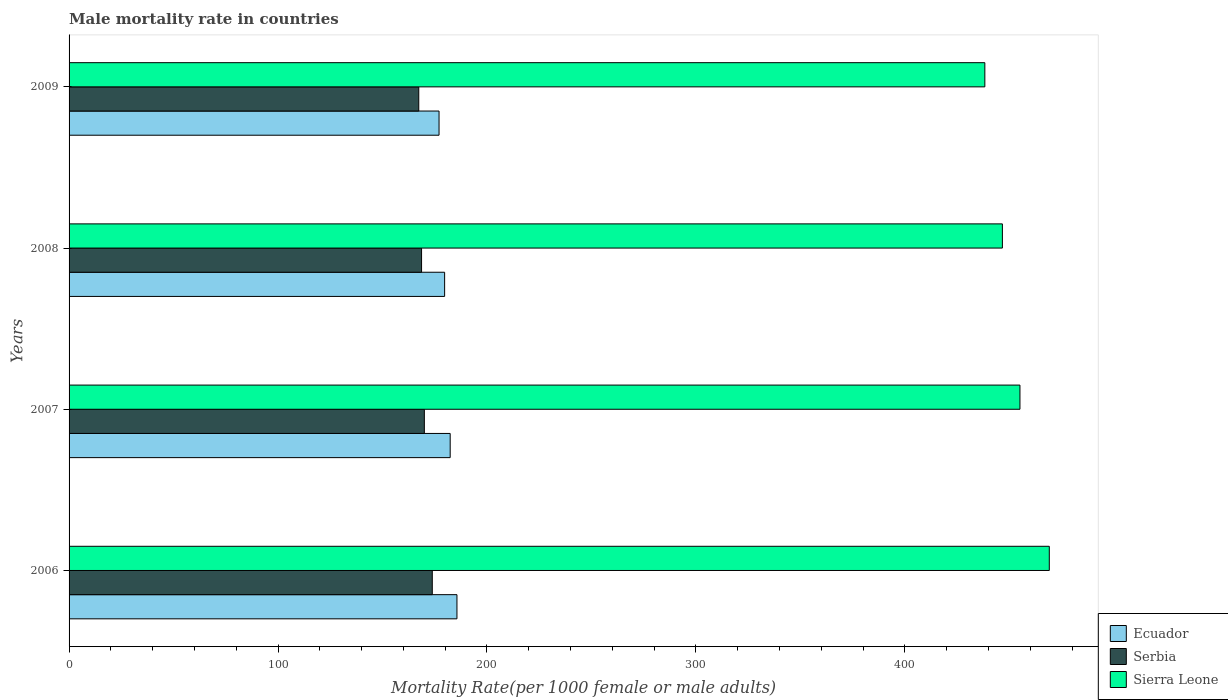How many different coloured bars are there?
Provide a short and direct response. 3. Are the number of bars on each tick of the Y-axis equal?
Your answer should be very brief. Yes. How many bars are there on the 4th tick from the bottom?
Offer a terse response. 3. What is the label of the 4th group of bars from the top?
Offer a very short reply. 2006. What is the male mortality rate in Ecuador in 2007?
Your response must be concise. 182.4. Across all years, what is the maximum male mortality rate in Serbia?
Ensure brevity in your answer.  173.83. Across all years, what is the minimum male mortality rate in Sierra Leone?
Provide a succinct answer. 438.28. What is the total male mortality rate in Ecuador in the graph?
Provide a short and direct response. 724.83. What is the difference between the male mortality rate in Serbia in 2007 and that in 2008?
Ensure brevity in your answer.  1.34. What is the difference between the male mortality rate in Serbia in 2009 and the male mortality rate in Sierra Leone in 2008?
Give a very brief answer. -279.32. What is the average male mortality rate in Sierra Leone per year?
Keep it short and to the point. 452.29. In the year 2006, what is the difference between the male mortality rate in Sierra Leone and male mortality rate in Serbia?
Offer a very short reply. 295.29. In how many years, is the male mortality rate in Serbia greater than 280 ?
Give a very brief answer. 0. What is the ratio of the male mortality rate in Serbia in 2007 to that in 2009?
Give a very brief answer. 1.02. What is the difference between the highest and the second highest male mortality rate in Serbia?
Give a very brief answer. 3.8. What is the difference between the highest and the lowest male mortality rate in Sierra Leone?
Ensure brevity in your answer.  30.85. What does the 1st bar from the top in 2009 represents?
Make the answer very short. Sierra Leone. What does the 3rd bar from the bottom in 2008 represents?
Your answer should be compact. Sierra Leone. Is it the case that in every year, the sum of the male mortality rate in Serbia and male mortality rate in Sierra Leone is greater than the male mortality rate in Ecuador?
Your response must be concise. Yes. How many years are there in the graph?
Provide a succinct answer. 4. Are the values on the major ticks of X-axis written in scientific E-notation?
Ensure brevity in your answer.  No. Does the graph contain any zero values?
Your answer should be very brief. No. What is the title of the graph?
Keep it short and to the point. Male mortality rate in countries. Does "Venezuela" appear as one of the legend labels in the graph?
Your response must be concise. No. What is the label or title of the X-axis?
Offer a very short reply. Mortality Rate(per 1000 female or male adults). What is the label or title of the Y-axis?
Ensure brevity in your answer.  Years. What is the Mortality Rate(per 1000 female or male adults) in Ecuador in 2006?
Your answer should be compact. 185.63. What is the Mortality Rate(per 1000 female or male adults) in Serbia in 2006?
Provide a succinct answer. 173.83. What is the Mortality Rate(per 1000 female or male adults) in Sierra Leone in 2006?
Provide a short and direct response. 469.12. What is the Mortality Rate(per 1000 female or male adults) of Ecuador in 2007?
Offer a terse response. 182.4. What is the Mortality Rate(per 1000 female or male adults) in Serbia in 2007?
Your answer should be very brief. 170.03. What is the Mortality Rate(per 1000 female or male adults) of Sierra Leone in 2007?
Provide a succinct answer. 455.08. What is the Mortality Rate(per 1000 female or male adults) in Ecuador in 2008?
Make the answer very short. 179.73. What is the Mortality Rate(per 1000 female or male adults) of Serbia in 2008?
Provide a succinct answer. 168.7. What is the Mortality Rate(per 1000 female or male adults) in Sierra Leone in 2008?
Make the answer very short. 446.68. What is the Mortality Rate(per 1000 female or male adults) of Ecuador in 2009?
Keep it short and to the point. 177.07. What is the Mortality Rate(per 1000 female or male adults) in Serbia in 2009?
Ensure brevity in your answer.  167.36. What is the Mortality Rate(per 1000 female or male adults) of Sierra Leone in 2009?
Offer a very short reply. 438.28. Across all years, what is the maximum Mortality Rate(per 1000 female or male adults) in Ecuador?
Provide a succinct answer. 185.63. Across all years, what is the maximum Mortality Rate(per 1000 female or male adults) in Serbia?
Offer a terse response. 173.83. Across all years, what is the maximum Mortality Rate(per 1000 female or male adults) in Sierra Leone?
Offer a very short reply. 469.12. Across all years, what is the minimum Mortality Rate(per 1000 female or male adults) of Ecuador?
Your answer should be very brief. 177.07. Across all years, what is the minimum Mortality Rate(per 1000 female or male adults) in Serbia?
Your answer should be very brief. 167.36. Across all years, what is the minimum Mortality Rate(per 1000 female or male adults) of Sierra Leone?
Make the answer very short. 438.28. What is the total Mortality Rate(per 1000 female or male adults) in Ecuador in the graph?
Provide a short and direct response. 724.83. What is the total Mortality Rate(per 1000 female or male adults) in Serbia in the graph?
Offer a terse response. 679.92. What is the total Mortality Rate(per 1000 female or male adults) in Sierra Leone in the graph?
Ensure brevity in your answer.  1809.15. What is the difference between the Mortality Rate(per 1000 female or male adults) in Ecuador in 2006 and that in 2007?
Give a very brief answer. 3.24. What is the difference between the Mortality Rate(per 1000 female or male adults) of Serbia in 2006 and that in 2007?
Ensure brevity in your answer.  3.8. What is the difference between the Mortality Rate(per 1000 female or male adults) in Sierra Leone in 2006 and that in 2007?
Offer a terse response. 14.04. What is the difference between the Mortality Rate(per 1000 female or male adults) of Ecuador in 2006 and that in 2008?
Keep it short and to the point. 5.9. What is the difference between the Mortality Rate(per 1000 female or male adults) of Serbia in 2006 and that in 2008?
Offer a terse response. 5.13. What is the difference between the Mortality Rate(per 1000 female or male adults) in Sierra Leone in 2006 and that in 2008?
Give a very brief answer. 22.45. What is the difference between the Mortality Rate(per 1000 female or male adults) of Ecuador in 2006 and that in 2009?
Offer a terse response. 8.56. What is the difference between the Mortality Rate(per 1000 female or male adults) of Serbia in 2006 and that in 2009?
Provide a succinct answer. 6.47. What is the difference between the Mortality Rate(per 1000 female or male adults) in Sierra Leone in 2006 and that in 2009?
Provide a short and direct response. 30.85. What is the difference between the Mortality Rate(per 1000 female or male adults) of Ecuador in 2007 and that in 2008?
Give a very brief answer. 2.66. What is the difference between the Mortality Rate(per 1000 female or male adults) of Serbia in 2007 and that in 2008?
Offer a very short reply. 1.34. What is the difference between the Mortality Rate(per 1000 female or male adults) in Sierra Leone in 2007 and that in 2008?
Keep it short and to the point. 8.4. What is the difference between the Mortality Rate(per 1000 female or male adults) of Ecuador in 2007 and that in 2009?
Keep it short and to the point. 5.33. What is the difference between the Mortality Rate(per 1000 female or male adults) in Serbia in 2007 and that in 2009?
Provide a short and direct response. 2.67. What is the difference between the Mortality Rate(per 1000 female or male adults) in Sierra Leone in 2007 and that in 2009?
Give a very brief answer. 16.8. What is the difference between the Mortality Rate(per 1000 female or male adults) in Ecuador in 2008 and that in 2009?
Offer a terse response. 2.66. What is the difference between the Mortality Rate(per 1000 female or male adults) in Serbia in 2008 and that in 2009?
Provide a succinct answer. 1.34. What is the difference between the Mortality Rate(per 1000 female or male adults) in Sierra Leone in 2008 and that in 2009?
Make the answer very short. 8.4. What is the difference between the Mortality Rate(per 1000 female or male adults) in Ecuador in 2006 and the Mortality Rate(per 1000 female or male adults) in Serbia in 2007?
Offer a very short reply. 15.6. What is the difference between the Mortality Rate(per 1000 female or male adults) in Ecuador in 2006 and the Mortality Rate(per 1000 female or male adults) in Sierra Leone in 2007?
Your response must be concise. -269.44. What is the difference between the Mortality Rate(per 1000 female or male adults) of Serbia in 2006 and the Mortality Rate(per 1000 female or male adults) of Sierra Leone in 2007?
Ensure brevity in your answer.  -281.25. What is the difference between the Mortality Rate(per 1000 female or male adults) of Ecuador in 2006 and the Mortality Rate(per 1000 female or male adults) of Serbia in 2008?
Give a very brief answer. 16.94. What is the difference between the Mortality Rate(per 1000 female or male adults) of Ecuador in 2006 and the Mortality Rate(per 1000 female or male adults) of Sierra Leone in 2008?
Give a very brief answer. -261.04. What is the difference between the Mortality Rate(per 1000 female or male adults) of Serbia in 2006 and the Mortality Rate(per 1000 female or male adults) of Sierra Leone in 2008?
Offer a terse response. -272.85. What is the difference between the Mortality Rate(per 1000 female or male adults) in Ecuador in 2006 and the Mortality Rate(per 1000 female or male adults) in Serbia in 2009?
Keep it short and to the point. 18.27. What is the difference between the Mortality Rate(per 1000 female or male adults) in Ecuador in 2006 and the Mortality Rate(per 1000 female or male adults) in Sierra Leone in 2009?
Offer a terse response. -252.64. What is the difference between the Mortality Rate(per 1000 female or male adults) of Serbia in 2006 and the Mortality Rate(per 1000 female or male adults) of Sierra Leone in 2009?
Provide a short and direct response. -264.44. What is the difference between the Mortality Rate(per 1000 female or male adults) of Ecuador in 2007 and the Mortality Rate(per 1000 female or male adults) of Serbia in 2008?
Provide a succinct answer. 13.7. What is the difference between the Mortality Rate(per 1000 female or male adults) in Ecuador in 2007 and the Mortality Rate(per 1000 female or male adults) in Sierra Leone in 2008?
Your response must be concise. -264.28. What is the difference between the Mortality Rate(per 1000 female or male adults) in Serbia in 2007 and the Mortality Rate(per 1000 female or male adults) in Sierra Leone in 2008?
Your response must be concise. -276.64. What is the difference between the Mortality Rate(per 1000 female or male adults) in Ecuador in 2007 and the Mortality Rate(per 1000 female or male adults) in Serbia in 2009?
Keep it short and to the point. 15.04. What is the difference between the Mortality Rate(per 1000 female or male adults) of Ecuador in 2007 and the Mortality Rate(per 1000 female or male adults) of Sierra Leone in 2009?
Keep it short and to the point. -255.88. What is the difference between the Mortality Rate(per 1000 female or male adults) of Serbia in 2007 and the Mortality Rate(per 1000 female or male adults) of Sierra Leone in 2009?
Provide a short and direct response. -268.24. What is the difference between the Mortality Rate(per 1000 female or male adults) of Ecuador in 2008 and the Mortality Rate(per 1000 female or male adults) of Serbia in 2009?
Your answer should be very brief. 12.37. What is the difference between the Mortality Rate(per 1000 female or male adults) in Ecuador in 2008 and the Mortality Rate(per 1000 female or male adults) in Sierra Leone in 2009?
Ensure brevity in your answer.  -258.54. What is the difference between the Mortality Rate(per 1000 female or male adults) in Serbia in 2008 and the Mortality Rate(per 1000 female or male adults) in Sierra Leone in 2009?
Your response must be concise. -269.58. What is the average Mortality Rate(per 1000 female or male adults) in Ecuador per year?
Provide a short and direct response. 181.21. What is the average Mortality Rate(per 1000 female or male adults) in Serbia per year?
Offer a terse response. 169.98. What is the average Mortality Rate(per 1000 female or male adults) in Sierra Leone per year?
Provide a succinct answer. 452.29. In the year 2006, what is the difference between the Mortality Rate(per 1000 female or male adults) of Ecuador and Mortality Rate(per 1000 female or male adults) of Serbia?
Provide a succinct answer. 11.8. In the year 2006, what is the difference between the Mortality Rate(per 1000 female or male adults) in Ecuador and Mortality Rate(per 1000 female or male adults) in Sierra Leone?
Your response must be concise. -283.49. In the year 2006, what is the difference between the Mortality Rate(per 1000 female or male adults) of Serbia and Mortality Rate(per 1000 female or male adults) of Sierra Leone?
Your answer should be compact. -295.29. In the year 2007, what is the difference between the Mortality Rate(per 1000 female or male adults) in Ecuador and Mortality Rate(per 1000 female or male adults) in Serbia?
Keep it short and to the point. 12.37. In the year 2007, what is the difference between the Mortality Rate(per 1000 female or male adults) of Ecuador and Mortality Rate(per 1000 female or male adults) of Sierra Leone?
Make the answer very short. -272.68. In the year 2007, what is the difference between the Mortality Rate(per 1000 female or male adults) in Serbia and Mortality Rate(per 1000 female or male adults) in Sierra Leone?
Keep it short and to the point. -285.05. In the year 2008, what is the difference between the Mortality Rate(per 1000 female or male adults) of Ecuador and Mortality Rate(per 1000 female or male adults) of Serbia?
Provide a succinct answer. 11.04. In the year 2008, what is the difference between the Mortality Rate(per 1000 female or male adults) in Ecuador and Mortality Rate(per 1000 female or male adults) in Sierra Leone?
Make the answer very short. -266.94. In the year 2008, what is the difference between the Mortality Rate(per 1000 female or male adults) of Serbia and Mortality Rate(per 1000 female or male adults) of Sierra Leone?
Provide a short and direct response. -277.98. In the year 2009, what is the difference between the Mortality Rate(per 1000 female or male adults) of Ecuador and Mortality Rate(per 1000 female or male adults) of Serbia?
Offer a terse response. 9.71. In the year 2009, what is the difference between the Mortality Rate(per 1000 female or male adults) in Ecuador and Mortality Rate(per 1000 female or male adults) in Sierra Leone?
Your answer should be very brief. -261.21. In the year 2009, what is the difference between the Mortality Rate(per 1000 female or male adults) in Serbia and Mortality Rate(per 1000 female or male adults) in Sierra Leone?
Your answer should be compact. -270.91. What is the ratio of the Mortality Rate(per 1000 female or male adults) in Ecuador in 2006 to that in 2007?
Offer a terse response. 1.02. What is the ratio of the Mortality Rate(per 1000 female or male adults) of Serbia in 2006 to that in 2007?
Provide a succinct answer. 1.02. What is the ratio of the Mortality Rate(per 1000 female or male adults) of Sierra Leone in 2006 to that in 2007?
Offer a very short reply. 1.03. What is the ratio of the Mortality Rate(per 1000 female or male adults) in Ecuador in 2006 to that in 2008?
Your response must be concise. 1.03. What is the ratio of the Mortality Rate(per 1000 female or male adults) in Serbia in 2006 to that in 2008?
Ensure brevity in your answer.  1.03. What is the ratio of the Mortality Rate(per 1000 female or male adults) in Sierra Leone in 2006 to that in 2008?
Provide a succinct answer. 1.05. What is the ratio of the Mortality Rate(per 1000 female or male adults) of Ecuador in 2006 to that in 2009?
Provide a short and direct response. 1.05. What is the ratio of the Mortality Rate(per 1000 female or male adults) in Serbia in 2006 to that in 2009?
Your answer should be compact. 1.04. What is the ratio of the Mortality Rate(per 1000 female or male adults) of Sierra Leone in 2006 to that in 2009?
Your answer should be very brief. 1.07. What is the ratio of the Mortality Rate(per 1000 female or male adults) in Ecuador in 2007 to that in 2008?
Your answer should be compact. 1.01. What is the ratio of the Mortality Rate(per 1000 female or male adults) in Serbia in 2007 to that in 2008?
Make the answer very short. 1.01. What is the ratio of the Mortality Rate(per 1000 female or male adults) of Sierra Leone in 2007 to that in 2008?
Ensure brevity in your answer.  1.02. What is the ratio of the Mortality Rate(per 1000 female or male adults) of Ecuador in 2007 to that in 2009?
Your response must be concise. 1.03. What is the ratio of the Mortality Rate(per 1000 female or male adults) of Sierra Leone in 2007 to that in 2009?
Keep it short and to the point. 1.04. What is the ratio of the Mortality Rate(per 1000 female or male adults) of Sierra Leone in 2008 to that in 2009?
Ensure brevity in your answer.  1.02. What is the difference between the highest and the second highest Mortality Rate(per 1000 female or male adults) in Ecuador?
Provide a short and direct response. 3.24. What is the difference between the highest and the second highest Mortality Rate(per 1000 female or male adults) of Serbia?
Offer a very short reply. 3.8. What is the difference between the highest and the second highest Mortality Rate(per 1000 female or male adults) in Sierra Leone?
Your answer should be very brief. 14.04. What is the difference between the highest and the lowest Mortality Rate(per 1000 female or male adults) of Ecuador?
Give a very brief answer. 8.56. What is the difference between the highest and the lowest Mortality Rate(per 1000 female or male adults) in Serbia?
Give a very brief answer. 6.47. What is the difference between the highest and the lowest Mortality Rate(per 1000 female or male adults) in Sierra Leone?
Your answer should be very brief. 30.85. 